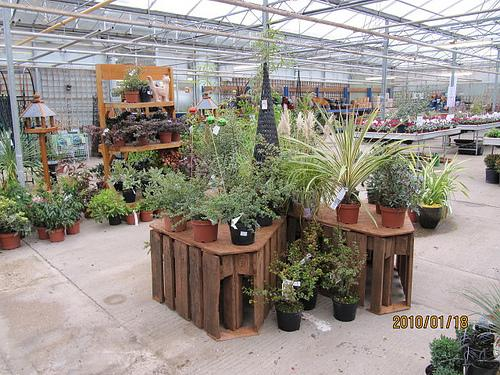What can be found here?

Choices:
A) cats
B) dogs
C) bats
D) pots pots 